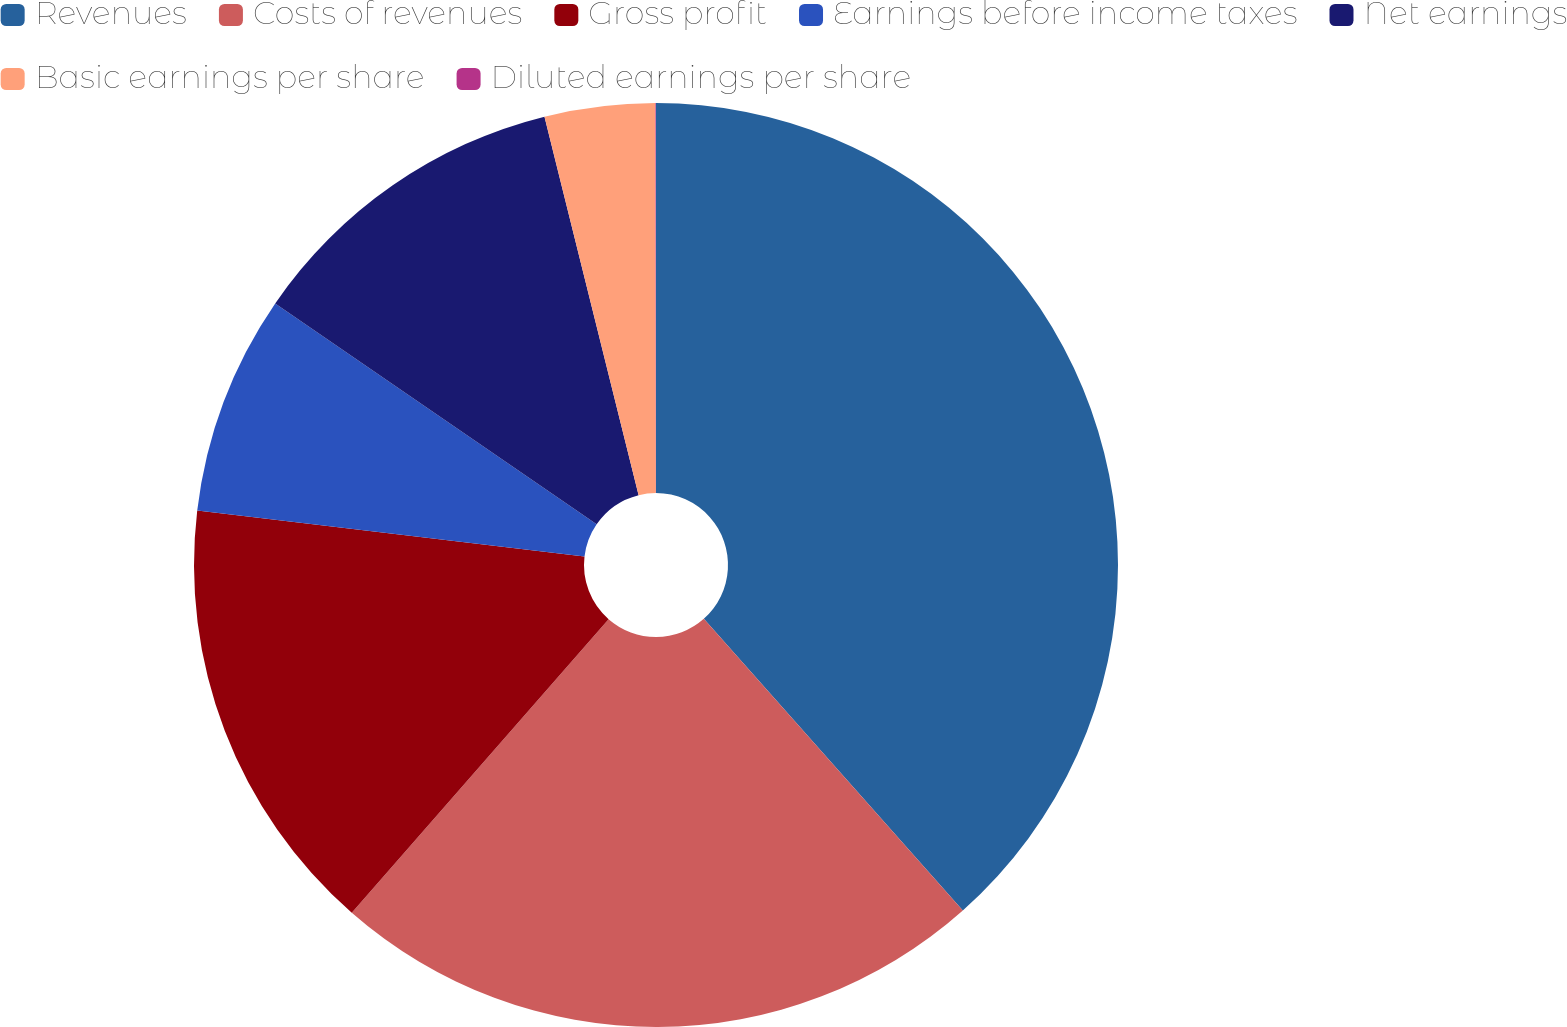Convert chart to OTSL. <chart><loc_0><loc_0><loc_500><loc_500><pie_chart><fcel>Revenues<fcel>Costs of revenues<fcel>Gross profit<fcel>Earnings before income taxes<fcel>Net earnings<fcel>Basic earnings per share<fcel>Diluted earnings per share<nl><fcel>38.44%<fcel>23.0%<fcel>15.44%<fcel>7.7%<fcel>11.54%<fcel>3.86%<fcel>0.02%<nl></chart> 